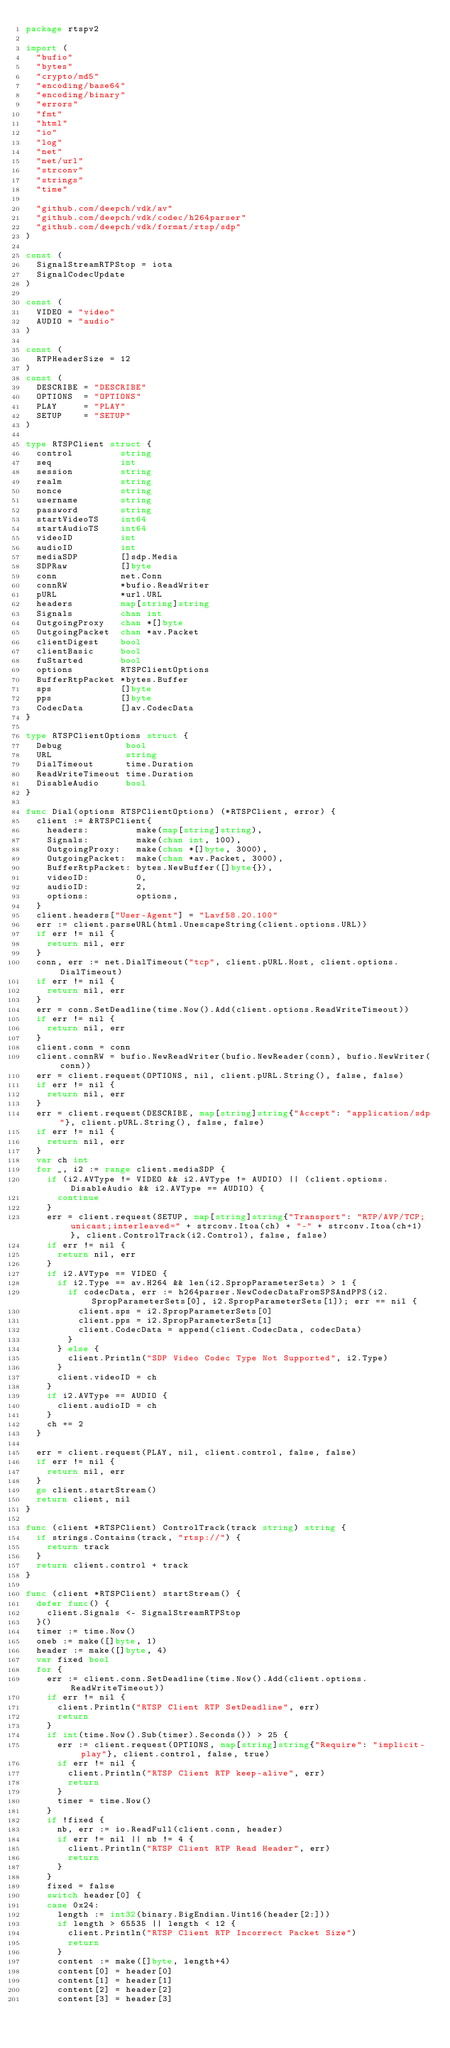<code> <loc_0><loc_0><loc_500><loc_500><_Go_>package rtspv2

import (
	"bufio"
	"bytes"
	"crypto/md5"
	"encoding/base64"
	"encoding/binary"
	"errors"
	"fmt"
	"html"
	"io"
	"log"
	"net"
	"net/url"
	"strconv"
	"strings"
	"time"

	"github.com/deepch/vdk/av"
	"github.com/deepch/vdk/codec/h264parser"
	"github.com/deepch/vdk/format/rtsp/sdp"
)

const (
	SignalStreamRTPStop = iota
	SignalCodecUpdate
)

const (
	VIDEO = "video"
	AUDIO = "audio"
)

const (
	RTPHeaderSize = 12
)
const (
	DESCRIBE = "DESCRIBE"
	OPTIONS  = "OPTIONS"
	PLAY     = "PLAY"
	SETUP    = "SETUP"
)

type RTSPClient struct {
	control         string
	seq             int
	session         string
	realm           string
	nonce           string
	username        string
	password        string
	startVideoTS    int64
	startAudioTS    int64
	videoID         int
	audioID         int
	mediaSDP        []sdp.Media
	SDPRaw          []byte
	conn            net.Conn
	connRW          *bufio.ReadWriter
	pURL            *url.URL
	headers         map[string]string
	Signals         chan int
	OutgoingProxy   chan *[]byte
	OutgoingPacket  chan *av.Packet
	clientDigest    bool
	clientBasic     bool
	fuStarted       bool
	options         RTSPClientOptions
	BufferRtpPacket *bytes.Buffer
	sps             []byte
	pps             []byte
	CodecData       []av.CodecData
}

type RTSPClientOptions struct {
	Debug            bool
	URL              string
	DialTimeout      time.Duration
	ReadWriteTimeout time.Duration
	DisableAudio     bool
}

func Dial(options RTSPClientOptions) (*RTSPClient, error) {
	client := &RTSPClient{
		headers:         make(map[string]string),
		Signals:         make(chan int, 100),
		OutgoingProxy:   make(chan *[]byte, 3000),
		OutgoingPacket:  make(chan *av.Packet, 3000),
		BufferRtpPacket: bytes.NewBuffer([]byte{}),
		videoID:         0,
		audioID:         2,
		options:         options,
	}
	client.headers["User-Agent"] = "Lavf58.20.100"
	err := client.parseURL(html.UnescapeString(client.options.URL))
	if err != nil {
		return nil, err
	}
	conn, err := net.DialTimeout("tcp", client.pURL.Host, client.options.DialTimeout)
	if err != nil {
		return nil, err
	}
	err = conn.SetDeadline(time.Now().Add(client.options.ReadWriteTimeout))
	if err != nil {
		return nil, err
	}
	client.conn = conn
	client.connRW = bufio.NewReadWriter(bufio.NewReader(conn), bufio.NewWriter(conn))
	err = client.request(OPTIONS, nil, client.pURL.String(), false, false)
	if err != nil {
		return nil, err
	}
	err = client.request(DESCRIBE, map[string]string{"Accept": "application/sdp"}, client.pURL.String(), false, false)
	if err != nil {
		return nil, err
	}
	var ch int
	for _, i2 := range client.mediaSDP {
		if (i2.AVType != VIDEO && i2.AVType != AUDIO) || (client.options.DisableAudio && i2.AVType == AUDIO) {
			continue
		}
		err = client.request(SETUP, map[string]string{"Transport": "RTP/AVP/TCP;unicast;interleaved=" + strconv.Itoa(ch) + "-" + strconv.Itoa(ch+1)}, client.ControlTrack(i2.Control), false, false)
		if err != nil {
			return nil, err
		}
		if i2.AVType == VIDEO {
			if i2.Type == av.H264 && len(i2.SpropParameterSets) > 1 {
				if codecData, err := h264parser.NewCodecDataFromSPSAndPPS(i2.SpropParameterSets[0], i2.SpropParameterSets[1]); err == nil {
					client.sps = i2.SpropParameterSets[0]
					client.pps = i2.SpropParameterSets[1]
					client.CodecData = append(client.CodecData, codecData)
				}
			} else {
				client.Println("SDP Video Codec Type Not Supported", i2.Type)
			}
			client.videoID = ch
		}
		if i2.AVType == AUDIO {
			client.audioID = ch
		}
		ch += 2
	}

	err = client.request(PLAY, nil, client.control, false, false)
	if err != nil {
		return nil, err
	}
	go client.startStream()
	return client, nil
}

func (client *RTSPClient) ControlTrack(track string) string {
	if strings.Contains(track, "rtsp://") {
		return track
	}
	return client.control + track
}

func (client *RTSPClient) startStream() {
	defer func() {
		client.Signals <- SignalStreamRTPStop
	}()
	timer := time.Now()
	oneb := make([]byte, 1)
	header := make([]byte, 4)
	var fixed bool
	for {
		err := client.conn.SetDeadline(time.Now().Add(client.options.ReadWriteTimeout))
		if err != nil {
			client.Println("RTSP Client RTP SetDeadline", err)
			return
		}
		if int(time.Now().Sub(timer).Seconds()) > 25 {
			err := client.request(OPTIONS, map[string]string{"Require": "implicit-play"}, client.control, false, true)
			if err != nil {
				client.Println("RTSP Client RTP keep-alive", err)
				return
			}
			timer = time.Now()
		}
		if !fixed {
			nb, err := io.ReadFull(client.conn, header)
			if err != nil || nb != 4 {
				client.Println("RTSP Client RTP Read Header", err)
				return
			}
		}
		fixed = false
		switch header[0] {
		case 0x24:
			length := int32(binary.BigEndian.Uint16(header[2:]))
			if length > 65535 || length < 12 {
				client.Println("RTSP Client RTP Incorrect Packet Size")
				return
			}
			content := make([]byte, length+4)
			content[0] = header[0]
			content[1] = header[1]
			content[2] = header[2]
			content[3] = header[3]</code> 